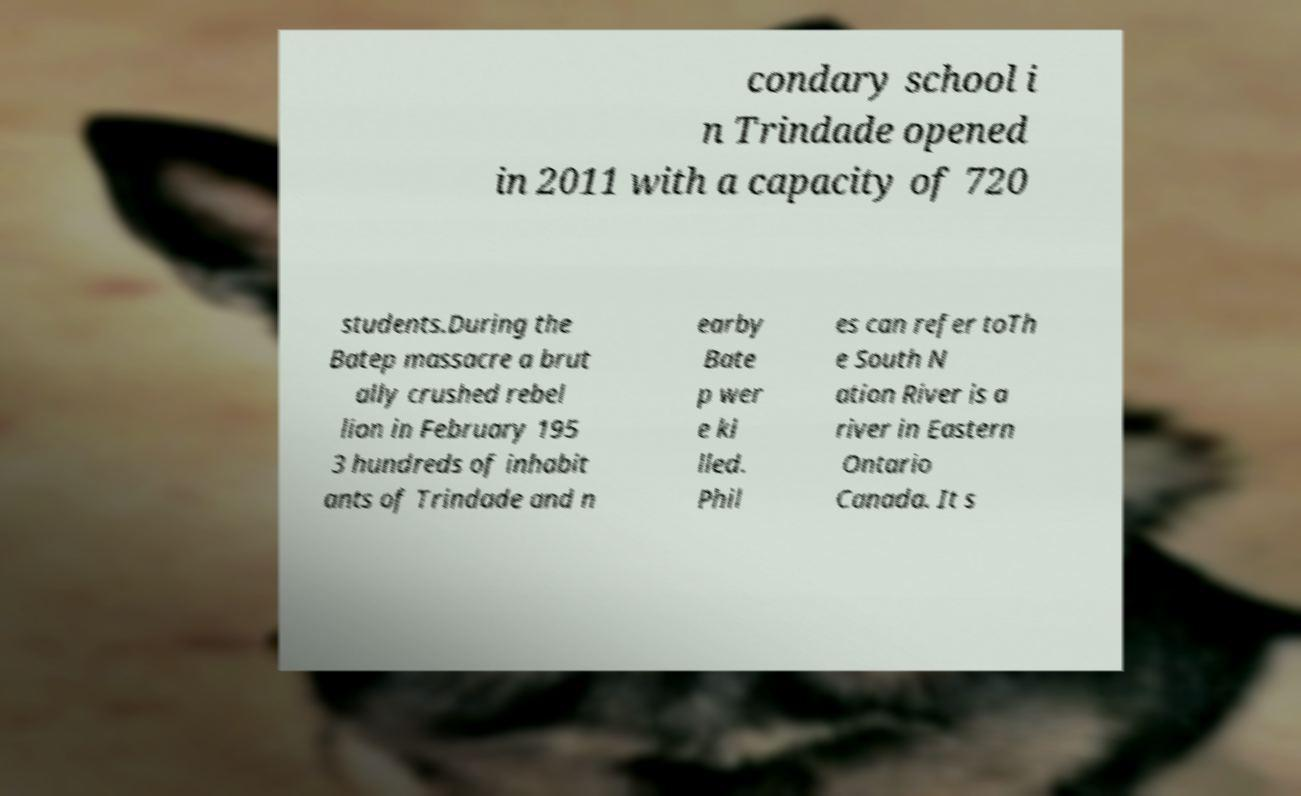Please identify and transcribe the text found in this image. condary school i n Trindade opened in 2011 with a capacity of 720 students.During the Batep massacre a brut ally crushed rebel lion in February 195 3 hundreds of inhabit ants of Trindade and n earby Bate p wer e ki lled. Phil es can refer toTh e South N ation River is a river in Eastern Ontario Canada. It s 